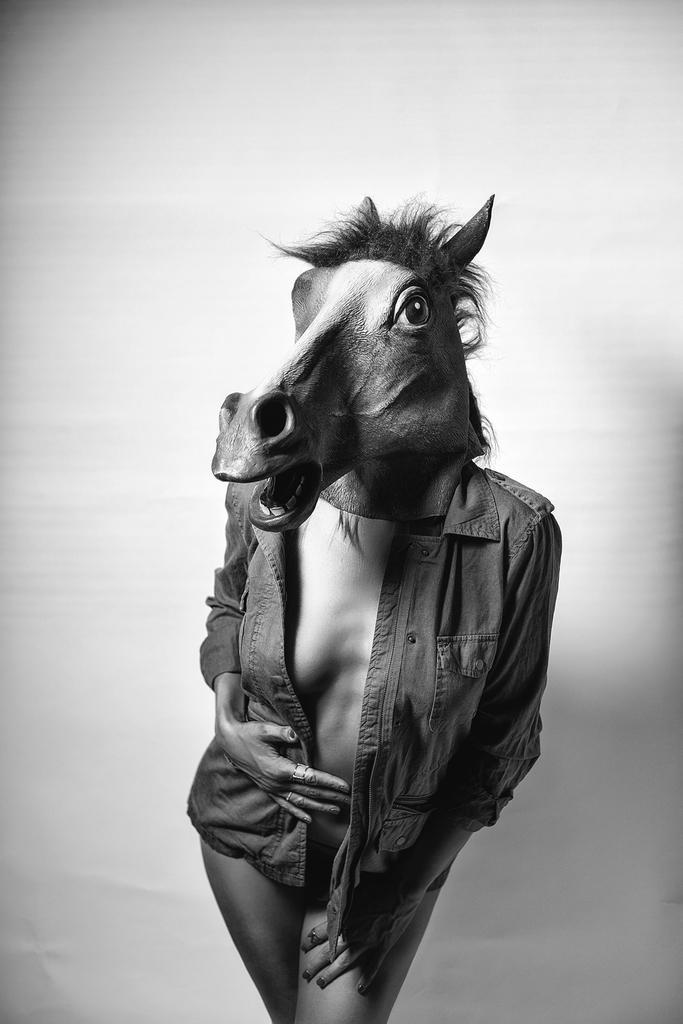Could you give a brief overview of what you see in this image? This is the picture of a woman wearing a mask of horse. She wear a jacket. And this is the black and white picture. 